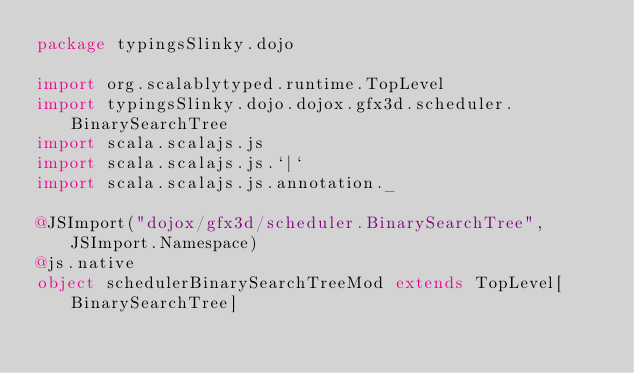<code> <loc_0><loc_0><loc_500><loc_500><_Scala_>package typingsSlinky.dojo

import org.scalablytyped.runtime.TopLevel
import typingsSlinky.dojo.dojox.gfx3d.scheduler.BinarySearchTree
import scala.scalajs.js
import scala.scalajs.js.`|`
import scala.scalajs.js.annotation._

@JSImport("dojox/gfx3d/scheduler.BinarySearchTree", JSImport.Namespace)
@js.native
object schedulerBinarySearchTreeMod extends TopLevel[BinarySearchTree]

</code> 